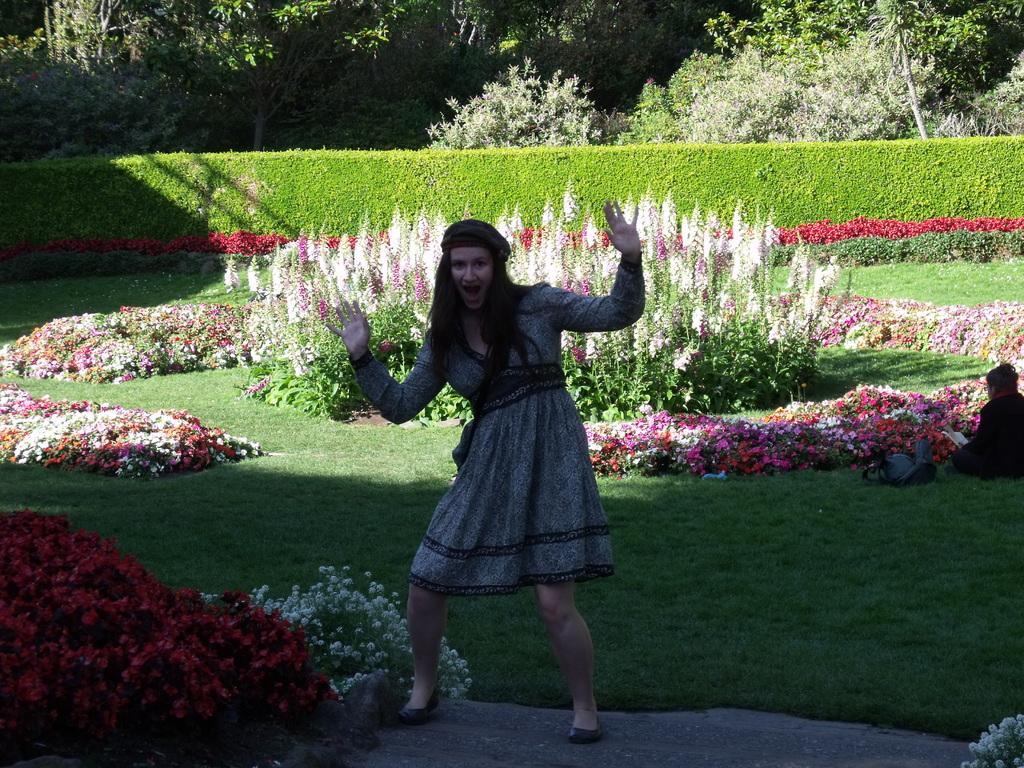In one or two sentences, can you explain what this image depicts? In this image there is a woman standing on a floor, in the background there is a garden in that there are flower plants and trees, there is a woman sitting in the garden. 